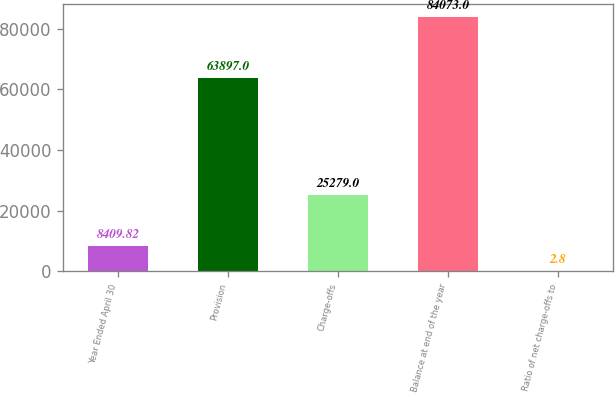Convert chart to OTSL. <chart><loc_0><loc_0><loc_500><loc_500><bar_chart><fcel>Year Ended April 30<fcel>Provision<fcel>Charge-offs<fcel>Balance at end of the year<fcel>Ratio of net charge-offs to<nl><fcel>8409.82<fcel>63897<fcel>25279<fcel>84073<fcel>2.8<nl></chart> 